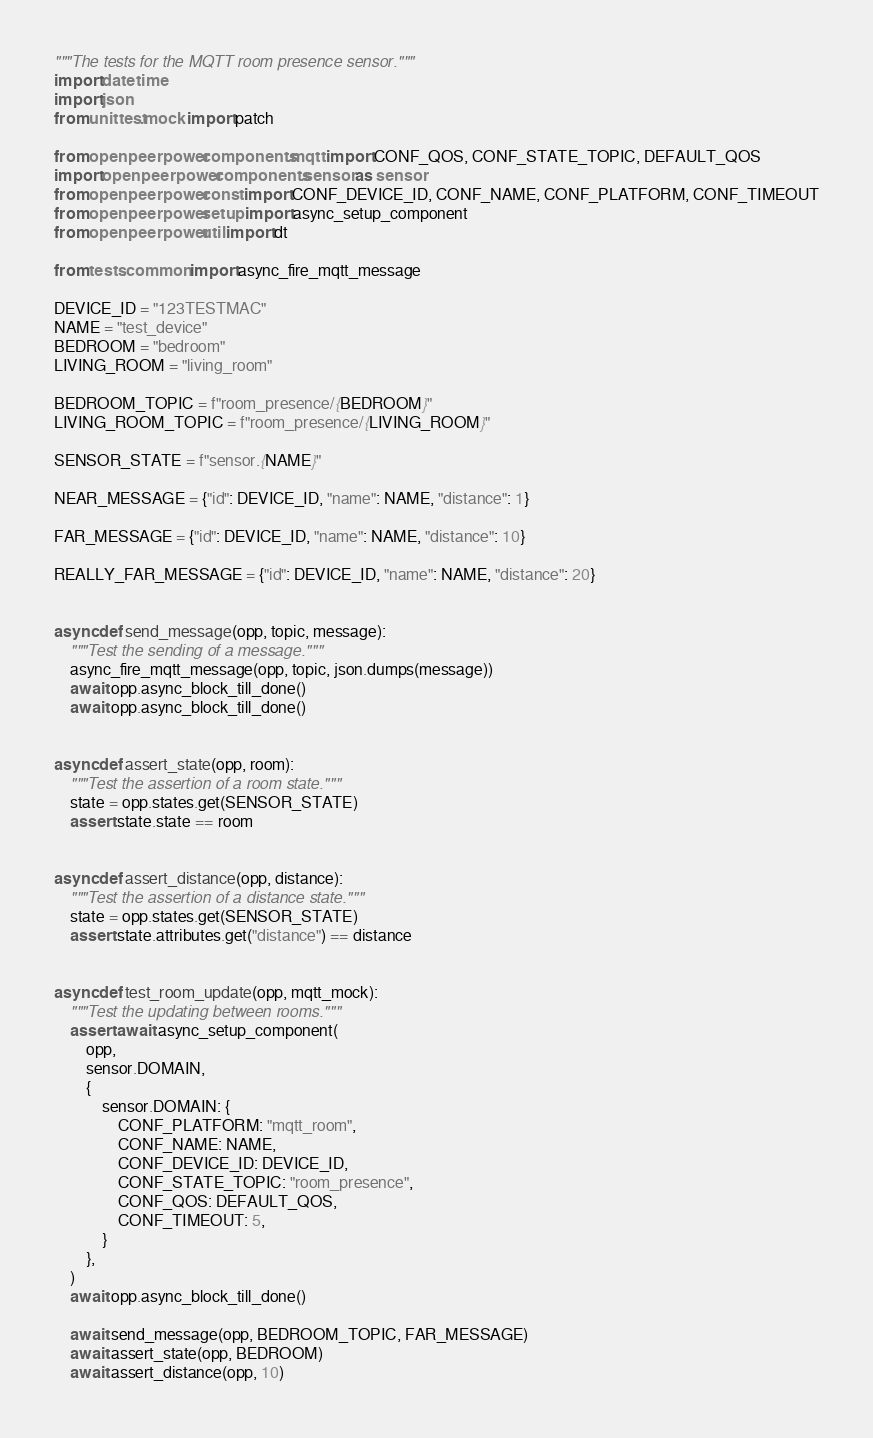Convert code to text. <code><loc_0><loc_0><loc_500><loc_500><_Python_>"""The tests for the MQTT room presence sensor."""
import datetime
import json
from unittest.mock import patch

from openpeerpower.components.mqtt import CONF_QOS, CONF_STATE_TOPIC, DEFAULT_QOS
import openpeerpower.components.sensor as sensor
from openpeerpower.const import CONF_DEVICE_ID, CONF_NAME, CONF_PLATFORM, CONF_TIMEOUT
from openpeerpower.setup import async_setup_component
from openpeerpower.util import dt

from tests.common import async_fire_mqtt_message

DEVICE_ID = "123TESTMAC"
NAME = "test_device"
BEDROOM = "bedroom"
LIVING_ROOM = "living_room"

BEDROOM_TOPIC = f"room_presence/{BEDROOM}"
LIVING_ROOM_TOPIC = f"room_presence/{LIVING_ROOM}"

SENSOR_STATE = f"sensor.{NAME}"

NEAR_MESSAGE = {"id": DEVICE_ID, "name": NAME, "distance": 1}

FAR_MESSAGE = {"id": DEVICE_ID, "name": NAME, "distance": 10}

REALLY_FAR_MESSAGE = {"id": DEVICE_ID, "name": NAME, "distance": 20}


async def send_message(opp, topic, message):
    """Test the sending of a message."""
    async_fire_mqtt_message(opp, topic, json.dumps(message))
    await opp.async_block_till_done()
    await opp.async_block_till_done()


async def assert_state(opp, room):
    """Test the assertion of a room state."""
    state = opp.states.get(SENSOR_STATE)
    assert state.state == room


async def assert_distance(opp, distance):
    """Test the assertion of a distance state."""
    state = opp.states.get(SENSOR_STATE)
    assert state.attributes.get("distance") == distance


async def test_room_update(opp, mqtt_mock):
    """Test the updating between rooms."""
    assert await async_setup_component(
        opp,
        sensor.DOMAIN,
        {
            sensor.DOMAIN: {
                CONF_PLATFORM: "mqtt_room",
                CONF_NAME: NAME,
                CONF_DEVICE_ID: DEVICE_ID,
                CONF_STATE_TOPIC: "room_presence",
                CONF_QOS: DEFAULT_QOS,
                CONF_TIMEOUT: 5,
            }
        },
    )
    await opp.async_block_till_done()

    await send_message(opp, BEDROOM_TOPIC, FAR_MESSAGE)
    await assert_state(opp, BEDROOM)
    await assert_distance(opp, 10)
</code> 